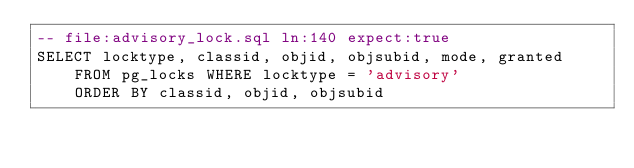Convert code to text. <code><loc_0><loc_0><loc_500><loc_500><_SQL_>-- file:advisory_lock.sql ln:140 expect:true
SELECT locktype, classid, objid, objsubid, mode, granted
	FROM pg_locks WHERE locktype = 'advisory'
	ORDER BY classid, objid, objsubid
</code> 